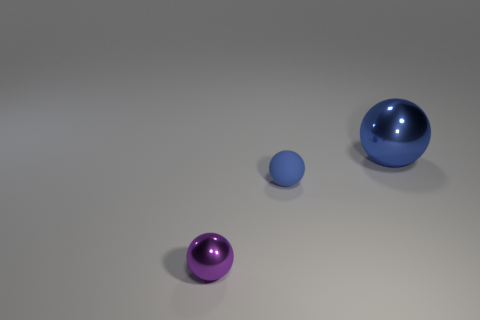How many objects are there, and can you describe their colors and textures? There are three objects in the image. Starting from the left, there's a small, purple sphere with a shiny, smooth surface. Next is a small, soft blue sphere with a matte texture. Finally, there's a larger blue sphere, also with a shiny, smooth texture. 